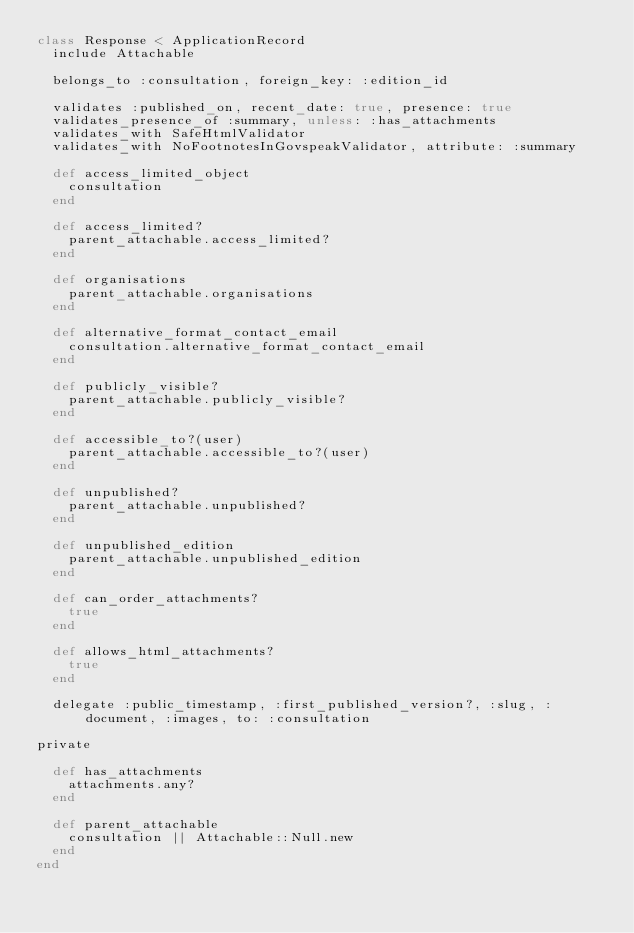<code> <loc_0><loc_0><loc_500><loc_500><_Ruby_>class Response < ApplicationRecord
  include Attachable

  belongs_to :consultation, foreign_key: :edition_id

  validates :published_on, recent_date: true, presence: true
  validates_presence_of :summary, unless: :has_attachments
  validates_with SafeHtmlValidator
  validates_with NoFootnotesInGovspeakValidator, attribute: :summary

  def access_limited_object
    consultation
  end

  def access_limited?
    parent_attachable.access_limited?
  end

  def organisations
    parent_attachable.organisations
  end

  def alternative_format_contact_email
    consultation.alternative_format_contact_email
  end

  def publicly_visible?
    parent_attachable.publicly_visible?
  end

  def accessible_to?(user)
    parent_attachable.accessible_to?(user)
  end

  def unpublished?
    parent_attachable.unpublished?
  end

  def unpublished_edition
    parent_attachable.unpublished_edition
  end

  def can_order_attachments?
    true
  end

  def allows_html_attachments?
    true
  end

  delegate :public_timestamp, :first_published_version?, :slug, :document, :images, to: :consultation

private

  def has_attachments
    attachments.any?
  end

  def parent_attachable
    consultation || Attachable::Null.new
  end
end
</code> 